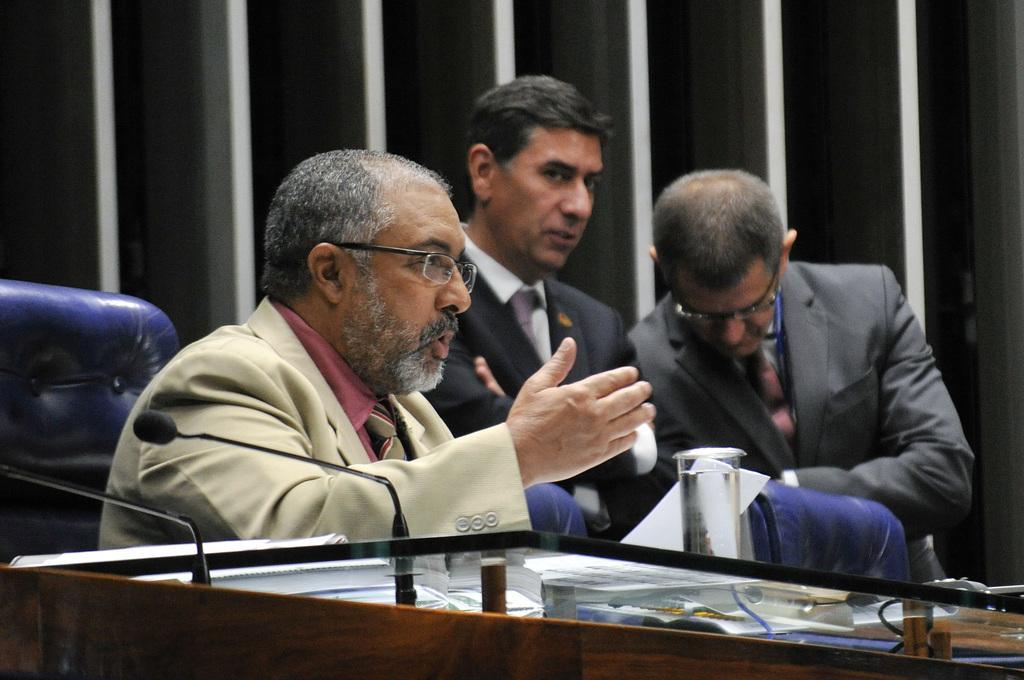Could you give a brief overview of what you see in this image? In the center of the image we can see three persons are sitting on a chair. At the bottom of the image there is a table. On the table we can see mics, paper, glass are there. In the background of the image there is a wall. 